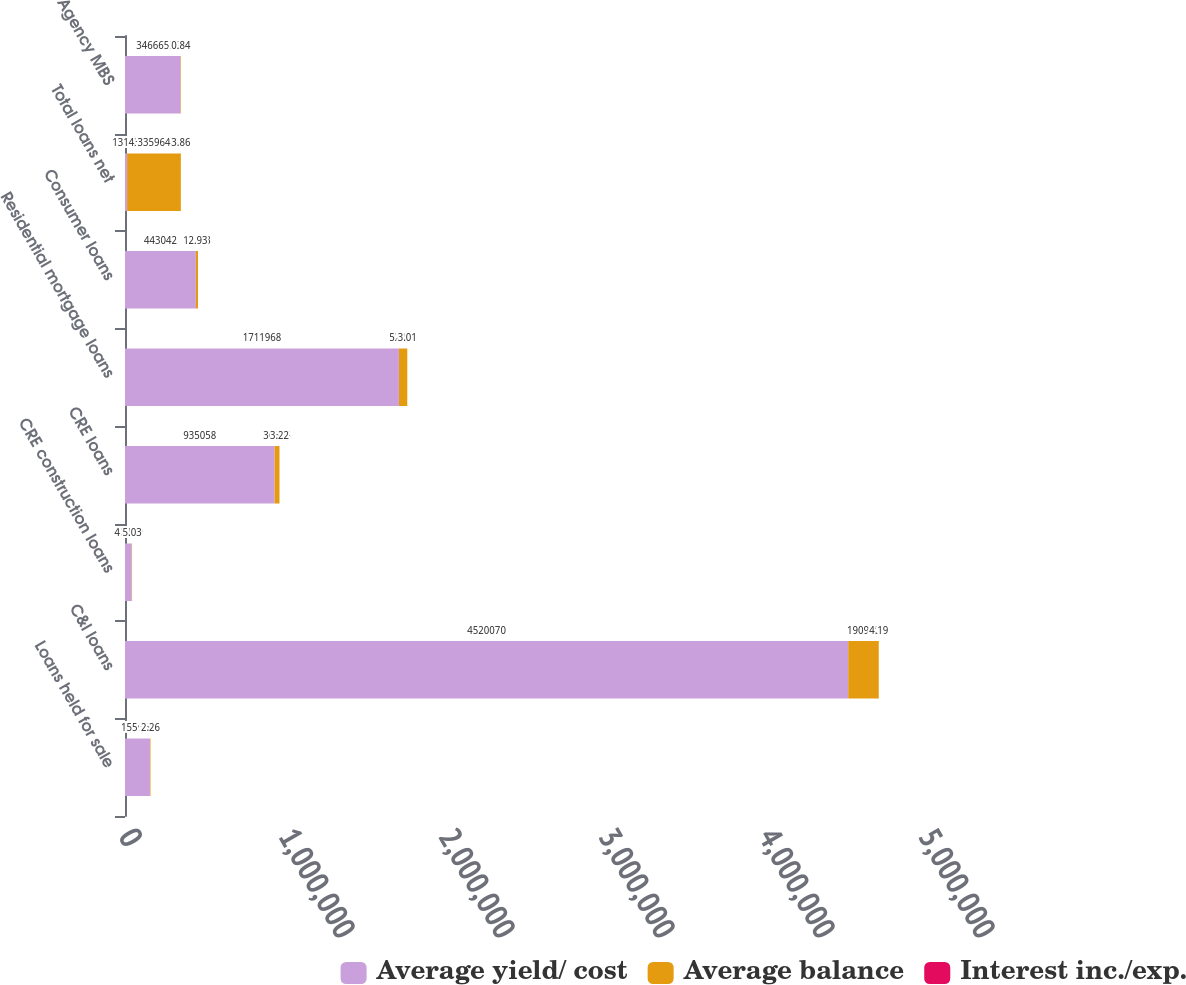<chart> <loc_0><loc_0><loc_500><loc_500><stacked_bar_chart><ecel><fcel>Loans held for sale<fcel>C&I loans<fcel>CRE construction loans<fcel>CRE loans<fcel>Residential mortgage loans<fcel>Consumer loans<fcel>Total loans net<fcel>Agency MBS<nl><fcel>Average yield/ cost<fcel>155901<fcel>4.52007e+06<fcel>41928<fcel>935058<fcel>1.71197e+06<fcel>443042<fcel>13143<fcel>346665<nl><fcel>Average balance<fcel>3519<fcel>190910<fcel>2140<fcel>30515<fcel>52285<fcel>13143<fcel>335964<fcel>2902<nl><fcel>Interest inc./exp.<fcel>2.26<fcel>4.19<fcel>5.03<fcel>3.22<fcel>3.01<fcel>2.93<fcel>3.86<fcel>0.84<nl></chart> 